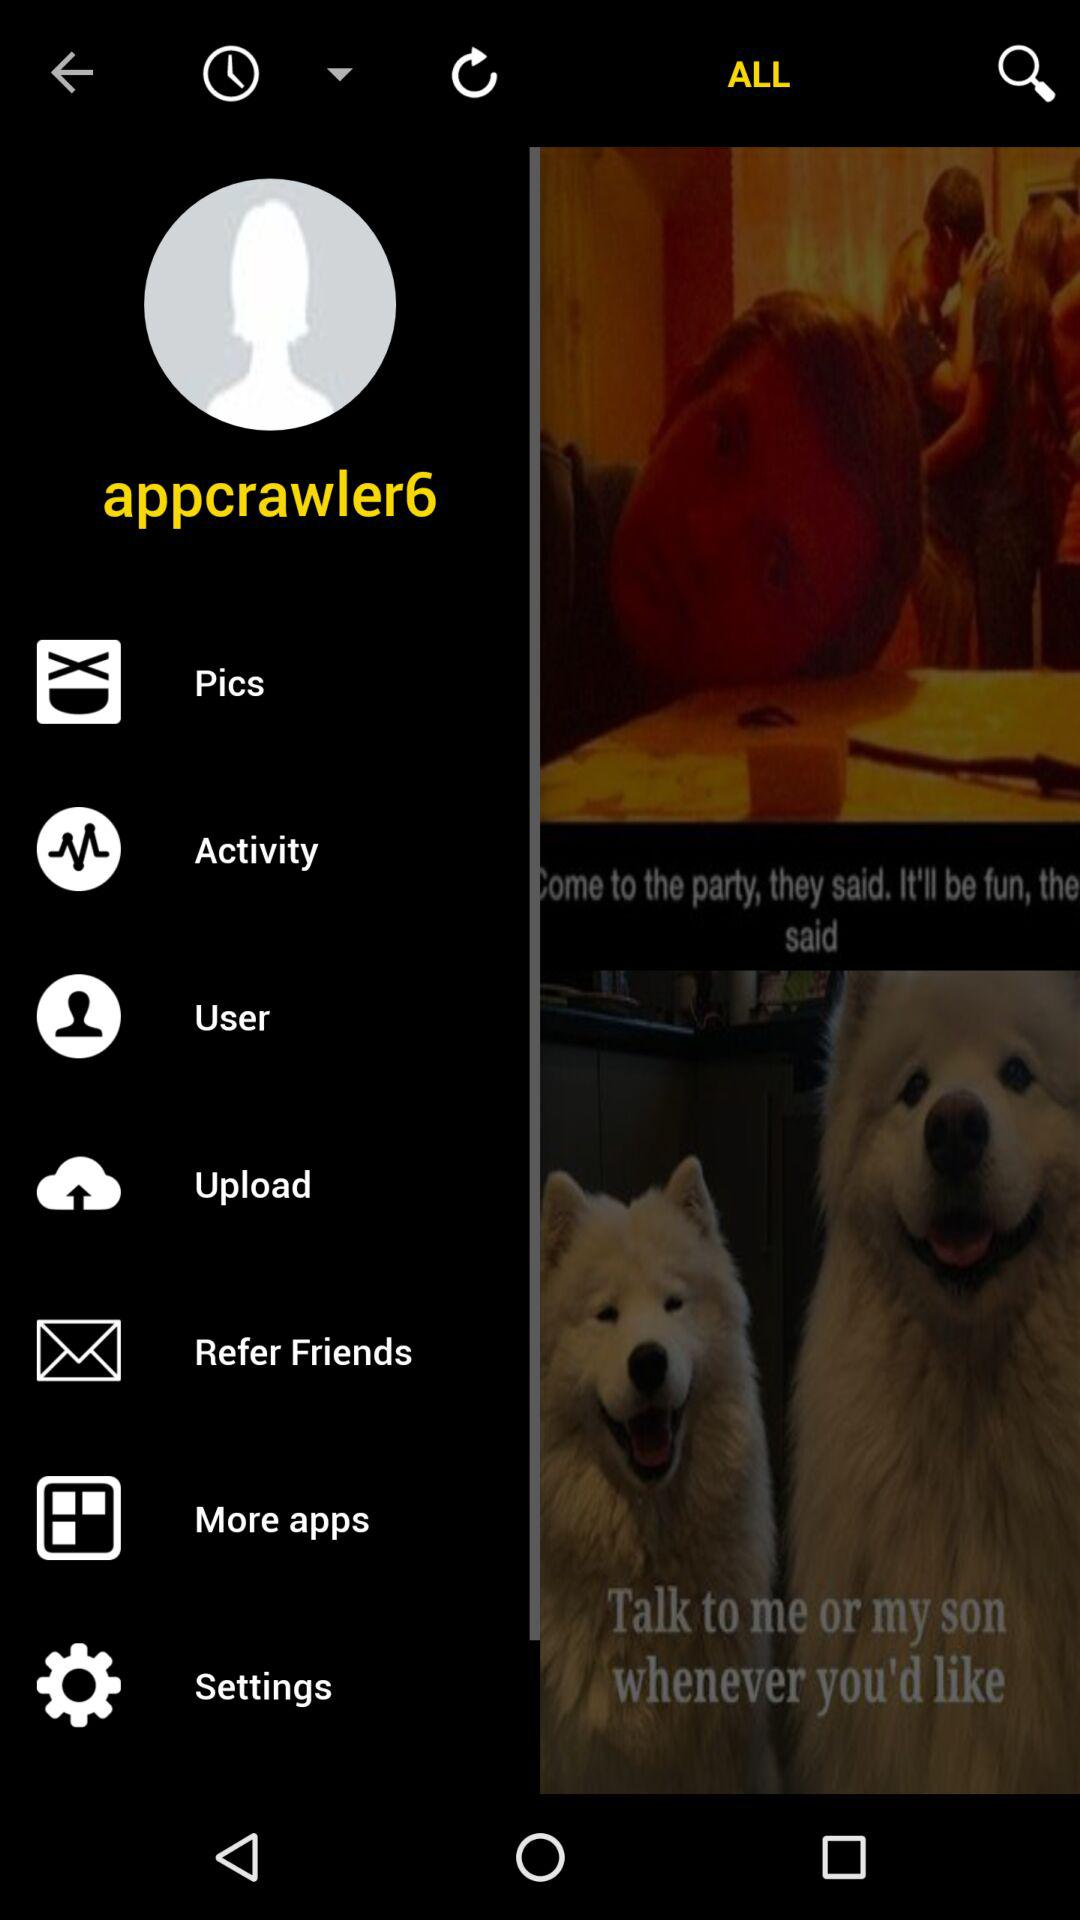What is the user name? The user name is Appcrawler6. 